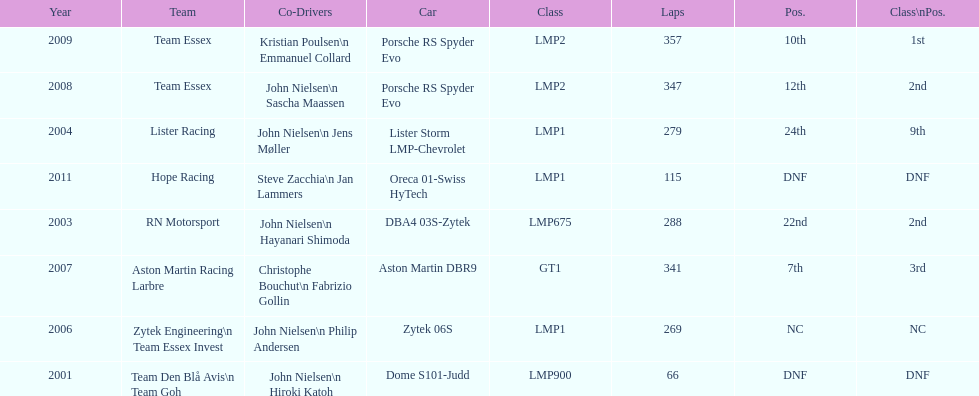During the 24 hours of le mans, who partnered with casper elgaard the most? John Nielsen. Give me the full table as a dictionary. {'header': ['Year', 'Team', 'Co-Drivers', 'Car', 'Class', 'Laps', 'Pos.', 'Class\\nPos.'], 'rows': [['2009', 'Team Essex', 'Kristian Poulsen\\n Emmanuel Collard', 'Porsche RS Spyder Evo', 'LMP2', '357', '10th', '1st'], ['2008', 'Team Essex', 'John Nielsen\\n Sascha Maassen', 'Porsche RS Spyder Evo', 'LMP2', '347', '12th', '2nd'], ['2004', 'Lister Racing', 'John Nielsen\\n Jens Møller', 'Lister Storm LMP-Chevrolet', 'LMP1', '279', '24th', '9th'], ['2011', 'Hope Racing', 'Steve Zacchia\\n Jan Lammers', 'Oreca 01-Swiss HyTech', 'LMP1', '115', 'DNF', 'DNF'], ['2003', 'RN Motorsport', 'John Nielsen\\n Hayanari Shimoda', 'DBA4 03S-Zytek', 'LMP675', '288', '22nd', '2nd'], ['2007', 'Aston Martin Racing Larbre', 'Christophe Bouchut\\n Fabrizio Gollin', 'Aston Martin DBR9', 'GT1', '341', '7th', '3rd'], ['2006', 'Zytek Engineering\\n Team Essex Invest', 'John Nielsen\\n Philip Andersen', 'Zytek 06S', 'LMP1', '269', 'NC', 'NC'], ['2001', 'Team Den Blå Avis\\n Team Goh', 'John Nielsen\\n Hiroki Katoh', 'Dome S101-Judd', 'LMP900', '66', 'DNF', 'DNF']]} 